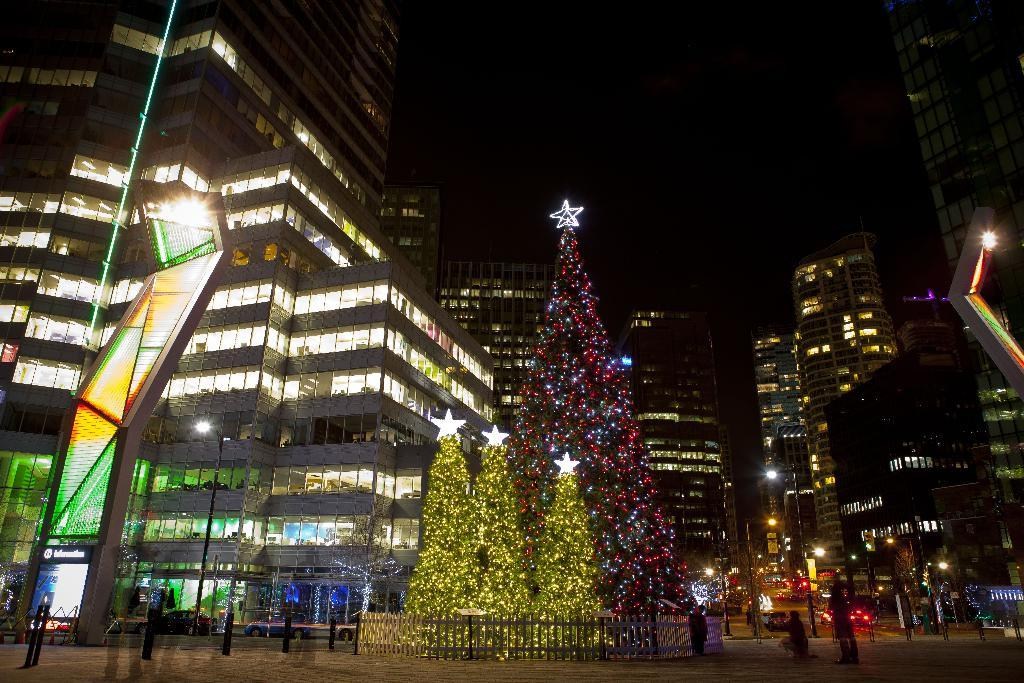What is the main subject in the foreground of the image? There is a Christmas tree with lighting in the foreground of the image. What are the people in the image doing? A group of persons are standing on the road. What can be seen in the background of the image? There are several buildings and the sky visible in the background of the image. How many dinosaurs can be seen walking on the road in the image? There are no dinosaurs present in the image; it features a Christmas tree and a group of people standing on the road. What type of oatmeal is being served at the event in the image? There is no event or oatmeal present in the image; it shows a Christmas tree and people standing on the road. 